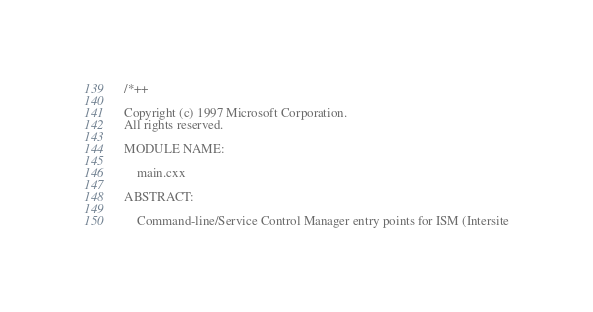Convert code to text. <code><loc_0><loc_0><loc_500><loc_500><_C++_>/*++

Copyright (c) 1997 Microsoft Corporation.
All rights reserved.

MODULE NAME:

    main.cxx

ABSTRACT:

    Command-line/Service Control Manager entry points for ISM (Intersite</code> 